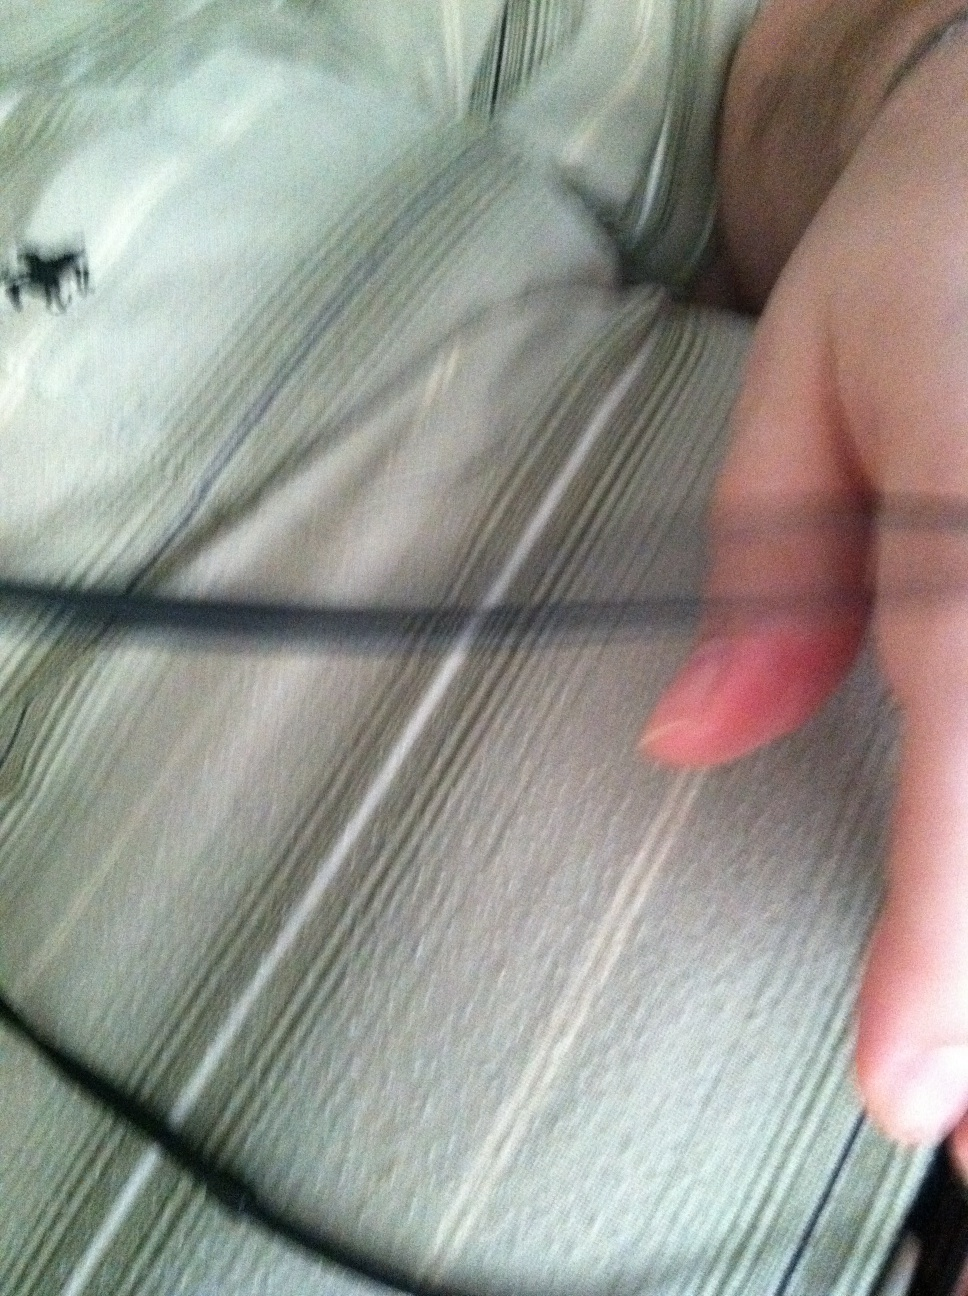What type of pattern is present on my shirt? The shirt features a striped pattern, which adds a classic and timeless touch to your outfit. 